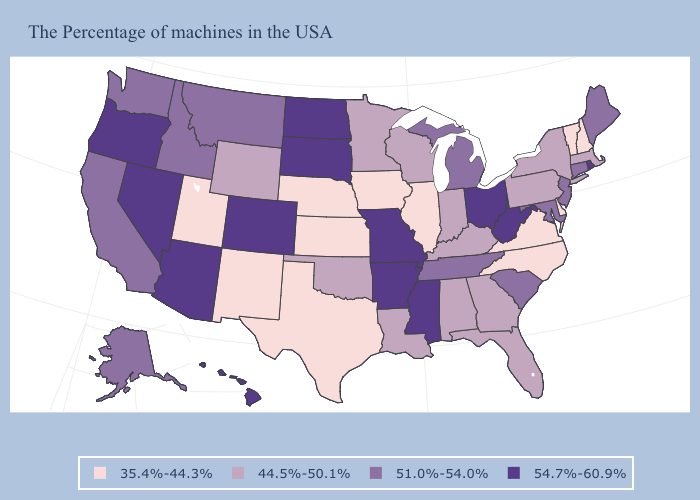Name the states that have a value in the range 44.5%-50.1%?
Concise answer only. Massachusetts, New York, Pennsylvania, Florida, Georgia, Kentucky, Indiana, Alabama, Wisconsin, Louisiana, Minnesota, Oklahoma, Wyoming. What is the highest value in the USA?
Be succinct. 54.7%-60.9%. Which states hav the highest value in the Northeast?
Keep it brief. Rhode Island. Name the states that have a value in the range 35.4%-44.3%?
Be succinct. New Hampshire, Vermont, Delaware, Virginia, North Carolina, Illinois, Iowa, Kansas, Nebraska, Texas, New Mexico, Utah. What is the value of Arizona?
Be succinct. 54.7%-60.9%. What is the value of Nevada?
Concise answer only. 54.7%-60.9%. Does Colorado have the lowest value in the West?
Write a very short answer. No. Which states have the lowest value in the MidWest?
Give a very brief answer. Illinois, Iowa, Kansas, Nebraska. Name the states that have a value in the range 35.4%-44.3%?
Answer briefly. New Hampshire, Vermont, Delaware, Virginia, North Carolina, Illinois, Iowa, Kansas, Nebraska, Texas, New Mexico, Utah. What is the value of Delaware?
Answer briefly. 35.4%-44.3%. Does Oklahoma have a higher value than Nebraska?
Concise answer only. Yes. Which states have the highest value in the USA?
Short answer required. Rhode Island, West Virginia, Ohio, Mississippi, Missouri, Arkansas, South Dakota, North Dakota, Colorado, Arizona, Nevada, Oregon, Hawaii. What is the lowest value in the USA?
Short answer required. 35.4%-44.3%. What is the lowest value in the Northeast?
Give a very brief answer. 35.4%-44.3%. Which states have the lowest value in the USA?
Concise answer only. New Hampshire, Vermont, Delaware, Virginia, North Carolina, Illinois, Iowa, Kansas, Nebraska, Texas, New Mexico, Utah. 